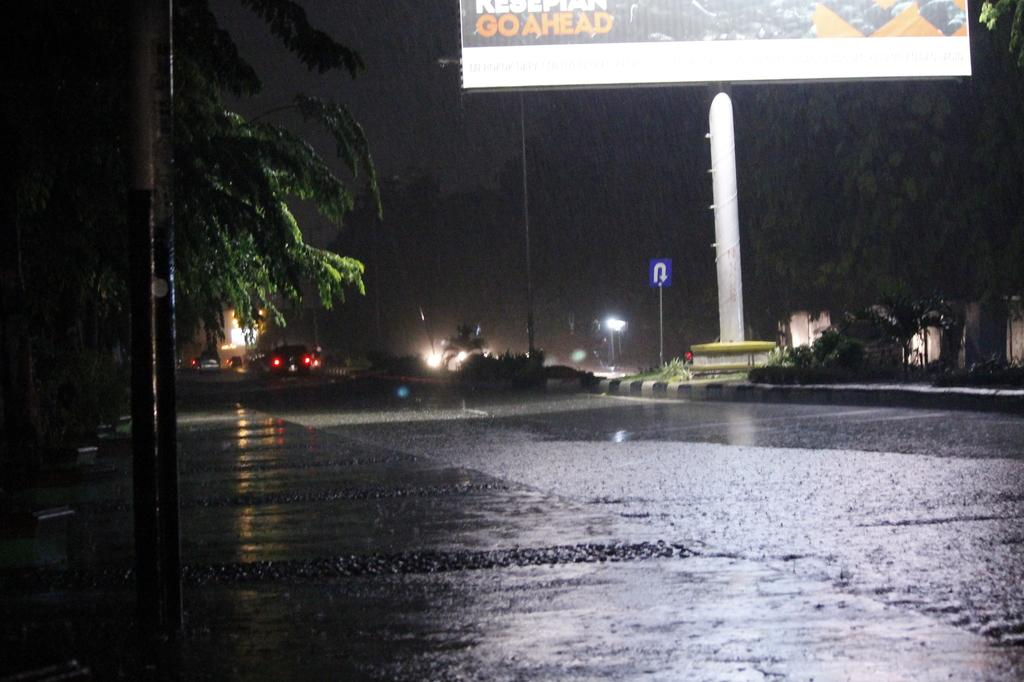What is happening on the road in the image? There are vehicles moving on the road in the image. What can be seen beside the road in the image? There are trees and plants beside the road in the image. What type of cheese is being sold at the pump in the image? There is no pump or cheese present in the image; it features vehicles moving on a road with trees and plants beside it. 